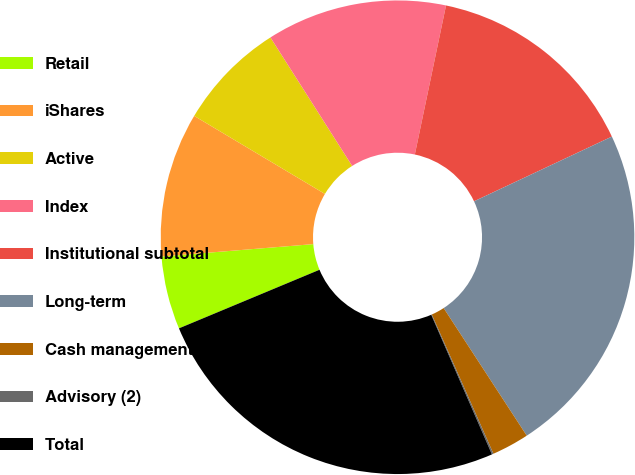Convert chart. <chart><loc_0><loc_0><loc_500><loc_500><pie_chart><fcel>Retail<fcel>iShares<fcel>Active<fcel>Index<fcel>Institutional subtotal<fcel>Long-term<fcel>Cash management<fcel>Advisory (2)<fcel>Total<nl><fcel>4.99%<fcel>9.86%<fcel>7.42%<fcel>12.3%<fcel>14.73%<fcel>22.8%<fcel>2.55%<fcel>0.11%<fcel>25.24%<nl></chart> 